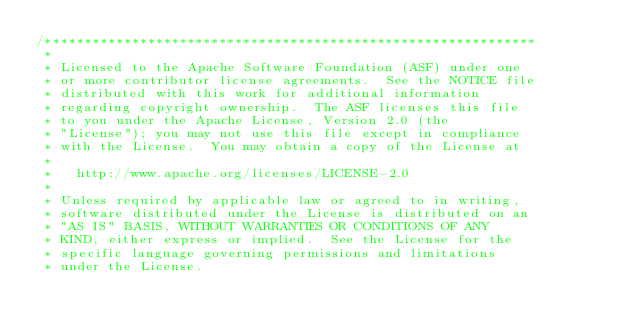Convert code to text. <code><loc_0><loc_0><loc_500><loc_500><_C++_>/**************************************************************
 * 
 * Licensed to the Apache Software Foundation (ASF) under one
 * or more contributor license agreements.  See the NOTICE file
 * distributed with this work for additional information
 * regarding copyright ownership.  The ASF licenses this file
 * to you under the Apache License, Version 2.0 (the
 * "License"); you may not use this file except in compliance
 * with the License.  You may obtain a copy of the License at
 * 
 *   http://www.apache.org/licenses/LICENSE-2.0
 * 
 * Unless required by applicable law or agreed to in writing,
 * software distributed under the License is distributed on an
 * "AS IS" BASIS, WITHOUT WARRANTIES OR CONDITIONS OF ANY
 * KIND, either express or implied.  See the License for the
 * specific language governing permissions and limitations
 * under the License.</code> 